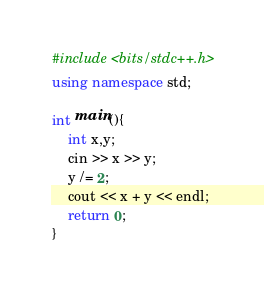<code> <loc_0><loc_0><loc_500><loc_500><_C++_>#include <bits/stdc++.h>
using namespace std;

int main(){
    int x,y;
    cin >> x >> y;
    y /= 2;
    cout << x + y << endl;
    return 0;
}</code> 